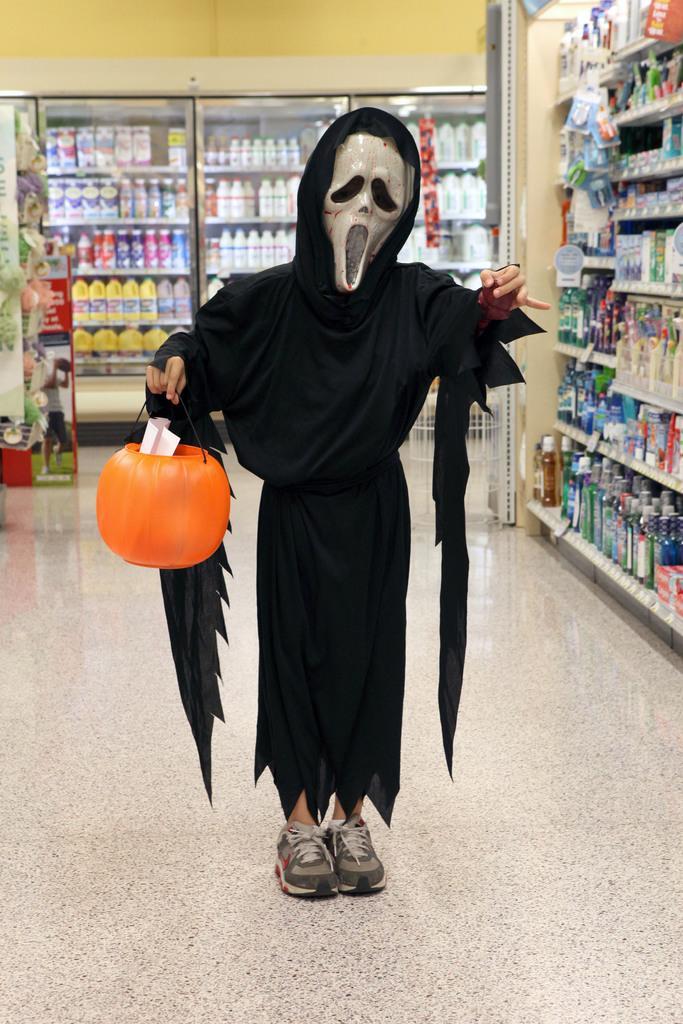Describe this image in one or two sentences. In this image in the center there is one person who is wearing same costume, and he is holding a pumpkin. And in the background there are some racks, and in the racks there are some groceries and glass door and some other objects. At the bottom there is floor. 